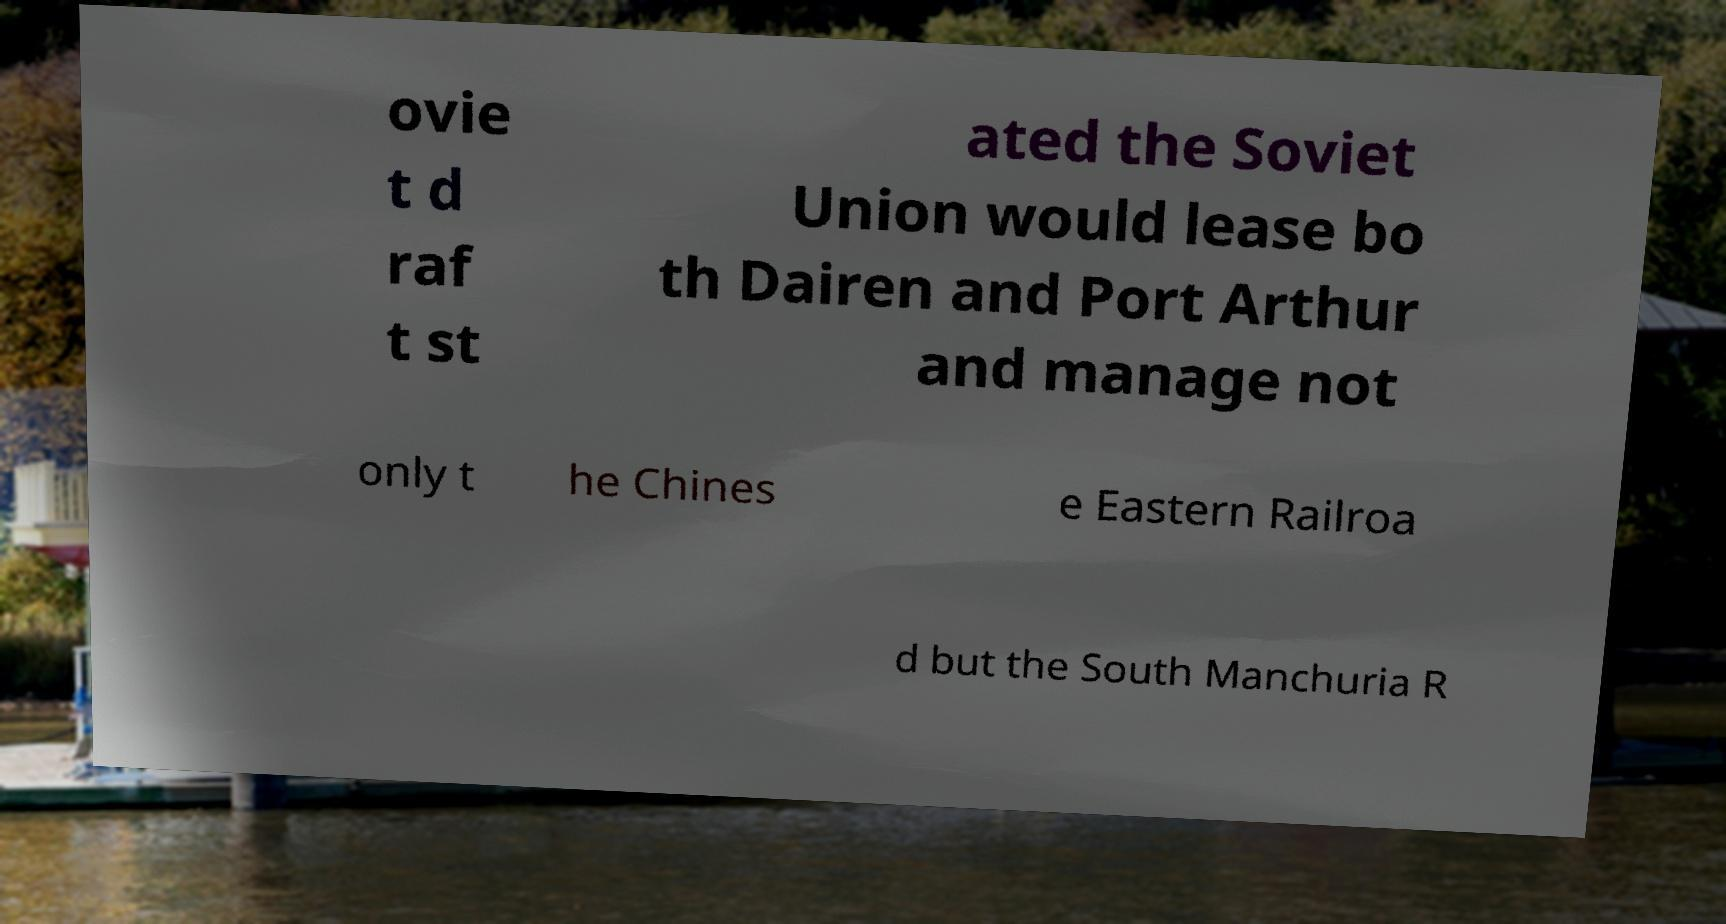Please read and relay the text visible in this image. What does it say? ovie t d raf t st ated the Soviet Union would lease bo th Dairen and Port Arthur and manage not only t he Chines e Eastern Railroa d but the South Manchuria R 